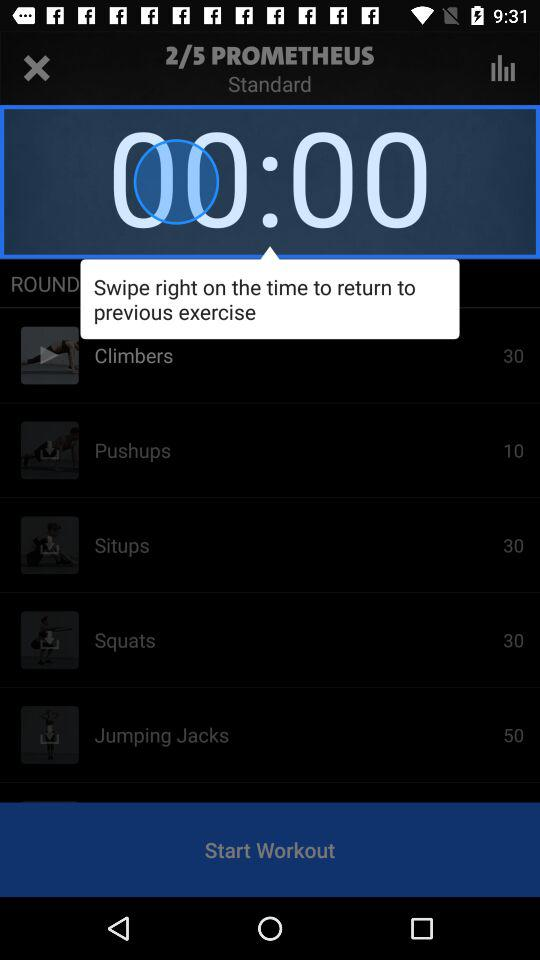How many exercises are in this workout?
Answer the question using a single word or phrase. 5 